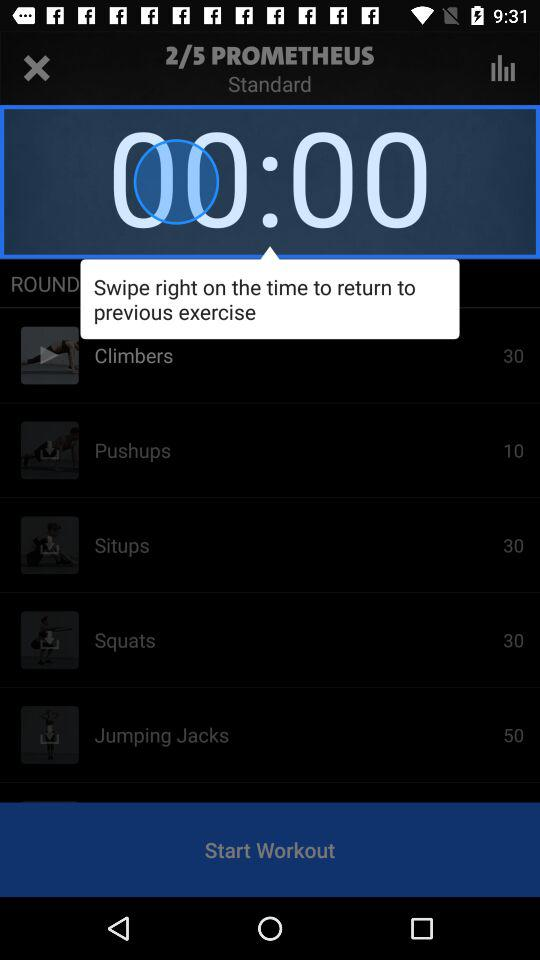How many exercises are in this workout?
Answer the question using a single word or phrase. 5 